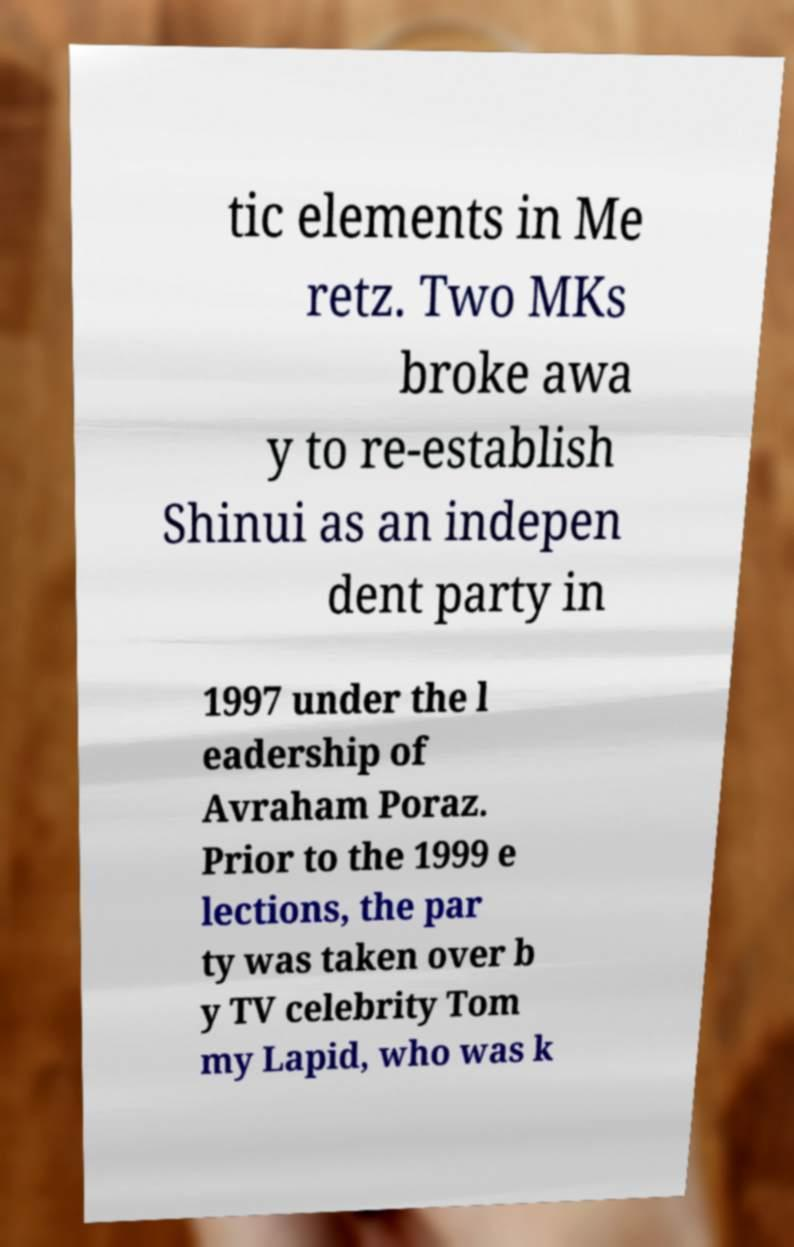What messages or text are displayed in this image? I need them in a readable, typed format. tic elements in Me retz. Two MKs broke awa y to re-establish Shinui as an indepen dent party in 1997 under the l eadership of Avraham Poraz. Prior to the 1999 e lections, the par ty was taken over b y TV celebrity Tom my Lapid, who was k 